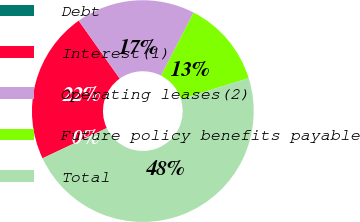Convert chart to OTSL. <chart><loc_0><loc_0><loc_500><loc_500><pie_chart><fcel>Debt<fcel>Interest(1)<fcel>Operating leases(2)<fcel>Future policy benefits payable<fcel>Total<nl><fcel>0.03%<fcel>22.17%<fcel>17.4%<fcel>12.62%<fcel>47.79%<nl></chart> 